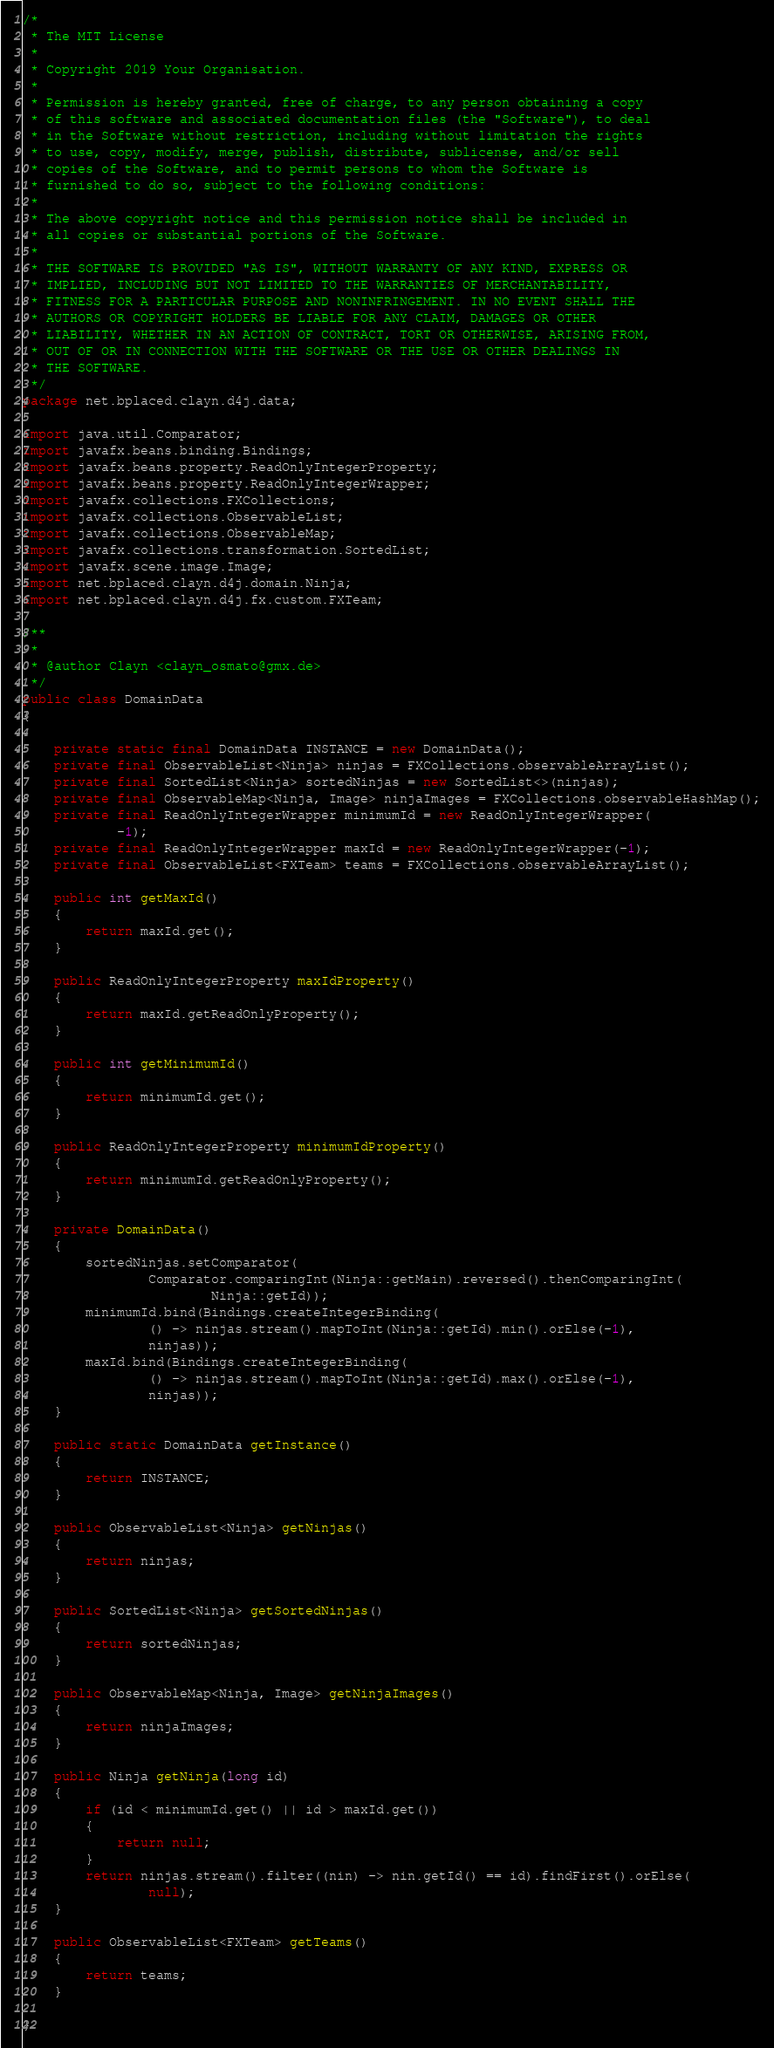<code> <loc_0><loc_0><loc_500><loc_500><_Java_>/*
 * The MIT License
 *
 * Copyright 2019 Your Organisation.
 *
 * Permission is hereby granted, free of charge, to any person obtaining a copy
 * of this software and associated documentation files (the "Software"), to deal
 * in the Software without restriction, including without limitation the rights
 * to use, copy, modify, merge, publish, distribute, sublicense, and/or sell
 * copies of the Software, and to permit persons to whom the Software is
 * furnished to do so, subject to the following conditions:
 *
 * The above copyright notice and this permission notice shall be included in
 * all copies or substantial portions of the Software.
 *
 * THE SOFTWARE IS PROVIDED "AS IS", WITHOUT WARRANTY OF ANY KIND, EXPRESS OR
 * IMPLIED, INCLUDING BUT NOT LIMITED TO THE WARRANTIES OF MERCHANTABILITY,
 * FITNESS FOR A PARTICULAR PURPOSE AND NONINFRINGEMENT. IN NO EVENT SHALL THE
 * AUTHORS OR COPYRIGHT HOLDERS BE LIABLE FOR ANY CLAIM, DAMAGES OR OTHER
 * LIABILITY, WHETHER IN AN ACTION OF CONTRACT, TORT OR OTHERWISE, ARISING FROM,
 * OUT OF OR IN CONNECTION WITH THE SOFTWARE OR THE USE OR OTHER DEALINGS IN
 * THE SOFTWARE.
 */
package net.bplaced.clayn.d4j.data;

import java.util.Comparator;
import javafx.beans.binding.Bindings;
import javafx.beans.property.ReadOnlyIntegerProperty;
import javafx.beans.property.ReadOnlyIntegerWrapper;
import javafx.collections.FXCollections;
import javafx.collections.ObservableList;
import javafx.collections.ObservableMap;
import javafx.collections.transformation.SortedList;
import javafx.scene.image.Image;
import net.bplaced.clayn.d4j.domain.Ninja;
import net.bplaced.clayn.d4j.fx.custom.FXTeam;

/**
 *
 * @author Clayn <clayn_osmato@gmx.de>
 */
public class DomainData
{

    private static final DomainData INSTANCE = new DomainData();
    private final ObservableList<Ninja> ninjas = FXCollections.observableArrayList();
    private final SortedList<Ninja> sortedNinjas = new SortedList<>(ninjas);
    private final ObservableMap<Ninja, Image> ninjaImages = FXCollections.observableHashMap();
    private final ReadOnlyIntegerWrapper minimumId = new ReadOnlyIntegerWrapper(
            -1);
    private final ReadOnlyIntegerWrapper maxId = new ReadOnlyIntegerWrapper(-1);
    private final ObservableList<FXTeam> teams = FXCollections.observableArrayList();

    public int getMaxId()
    {
        return maxId.get();
    }

    public ReadOnlyIntegerProperty maxIdProperty()
    {
        return maxId.getReadOnlyProperty();
    }

    public int getMinimumId()
    {
        return minimumId.get();
    }

    public ReadOnlyIntegerProperty minimumIdProperty()
    {
        return minimumId.getReadOnlyProperty();
    }

    private DomainData()
    {
        sortedNinjas.setComparator(
                Comparator.comparingInt(Ninja::getMain).reversed().thenComparingInt(
                        Ninja::getId));
        minimumId.bind(Bindings.createIntegerBinding(
                () -> ninjas.stream().mapToInt(Ninja::getId).min().orElse(-1),
                ninjas));
        maxId.bind(Bindings.createIntegerBinding(
                () -> ninjas.stream().mapToInt(Ninja::getId).max().orElse(-1),
                ninjas));
    }

    public static DomainData getInstance()
    {
        return INSTANCE;
    }

    public ObservableList<Ninja> getNinjas()
    {
        return ninjas;
    }

    public SortedList<Ninja> getSortedNinjas()
    {
        return sortedNinjas;
    }

    public ObservableMap<Ninja, Image> getNinjaImages()
    {
        return ninjaImages;
    }

    public Ninja getNinja(long id)
    {
        if (id < minimumId.get() || id > maxId.get())
        {
            return null;
        }
        return ninjas.stream().filter((nin) -> nin.getId() == id).findFirst().orElse(
                null);
    }

    public ObservableList<FXTeam> getTeams()
    {
        return teams;
    }

}
</code> 